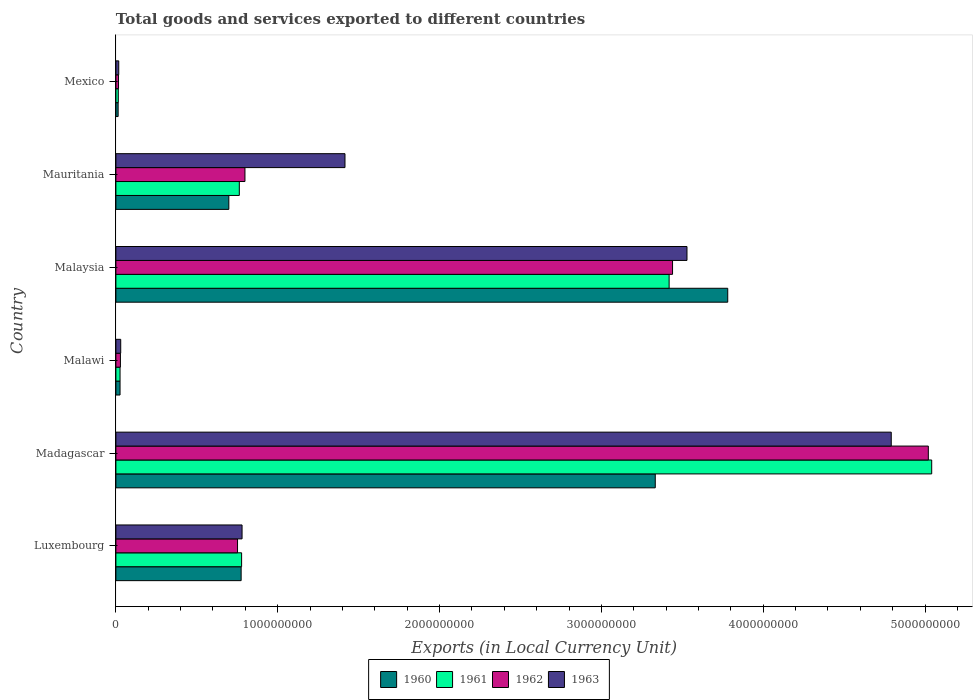How many different coloured bars are there?
Your answer should be compact. 4. How many bars are there on the 3rd tick from the top?
Your answer should be very brief. 4. What is the label of the 5th group of bars from the top?
Keep it short and to the point. Madagascar. What is the Amount of goods and services exports in 1962 in Luxembourg?
Provide a succinct answer. 7.52e+08. Across all countries, what is the maximum Amount of goods and services exports in 1960?
Your answer should be very brief. 3.78e+09. Across all countries, what is the minimum Amount of goods and services exports in 1960?
Make the answer very short. 1.39e+07. In which country was the Amount of goods and services exports in 1961 maximum?
Your answer should be compact. Madagascar. In which country was the Amount of goods and services exports in 1960 minimum?
Offer a very short reply. Mexico. What is the total Amount of goods and services exports in 1960 in the graph?
Your answer should be compact. 8.63e+09. What is the difference between the Amount of goods and services exports in 1963 in Madagascar and that in Mexico?
Provide a short and direct response. 4.77e+09. What is the difference between the Amount of goods and services exports in 1961 in Luxembourg and the Amount of goods and services exports in 1960 in Malawi?
Give a very brief answer. 7.51e+08. What is the average Amount of goods and services exports in 1961 per country?
Your response must be concise. 1.67e+09. What is the difference between the Amount of goods and services exports in 1962 and Amount of goods and services exports in 1960 in Malaysia?
Keep it short and to the point. -3.41e+08. In how many countries, is the Amount of goods and services exports in 1961 greater than 200000000 LCU?
Your answer should be compact. 4. What is the ratio of the Amount of goods and services exports in 1963 in Luxembourg to that in Malawi?
Ensure brevity in your answer.  26.16. Is the difference between the Amount of goods and services exports in 1962 in Mauritania and Mexico greater than the difference between the Amount of goods and services exports in 1960 in Mauritania and Mexico?
Offer a very short reply. Yes. What is the difference between the highest and the second highest Amount of goods and services exports in 1960?
Offer a terse response. 4.48e+08. What is the difference between the highest and the lowest Amount of goods and services exports in 1963?
Ensure brevity in your answer.  4.77e+09. In how many countries, is the Amount of goods and services exports in 1960 greater than the average Amount of goods and services exports in 1960 taken over all countries?
Your answer should be compact. 2. Is it the case that in every country, the sum of the Amount of goods and services exports in 1960 and Amount of goods and services exports in 1961 is greater than the sum of Amount of goods and services exports in 1963 and Amount of goods and services exports in 1962?
Provide a short and direct response. No. Is it the case that in every country, the sum of the Amount of goods and services exports in 1960 and Amount of goods and services exports in 1963 is greater than the Amount of goods and services exports in 1961?
Make the answer very short. Yes. Are all the bars in the graph horizontal?
Your answer should be compact. Yes. What is the title of the graph?
Ensure brevity in your answer.  Total goods and services exported to different countries. What is the label or title of the X-axis?
Your answer should be compact. Exports (in Local Currency Unit). What is the label or title of the Y-axis?
Ensure brevity in your answer.  Country. What is the Exports (in Local Currency Unit) in 1960 in Luxembourg?
Your response must be concise. 7.74e+08. What is the Exports (in Local Currency Unit) of 1961 in Luxembourg?
Give a very brief answer. 7.77e+08. What is the Exports (in Local Currency Unit) of 1962 in Luxembourg?
Your answer should be very brief. 7.52e+08. What is the Exports (in Local Currency Unit) in 1963 in Luxembourg?
Ensure brevity in your answer.  7.80e+08. What is the Exports (in Local Currency Unit) of 1960 in Madagascar?
Offer a terse response. 3.33e+09. What is the Exports (in Local Currency Unit) in 1961 in Madagascar?
Offer a very short reply. 5.04e+09. What is the Exports (in Local Currency Unit) in 1962 in Madagascar?
Provide a short and direct response. 5.02e+09. What is the Exports (in Local Currency Unit) of 1963 in Madagascar?
Offer a very short reply. 4.79e+09. What is the Exports (in Local Currency Unit) of 1960 in Malawi?
Give a very brief answer. 2.57e+07. What is the Exports (in Local Currency Unit) of 1961 in Malawi?
Give a very brief answer. 2.57e+07. What is the Exports (in Local Currency Unit) of 1962 in Malawi?
Keep it short and to the point. 2.80e+07. What is the Exports (in Local Currency Unit) of 1963 in Malawi?
Offer a terse response. 2.98e+07. What is the Exports (in Local Currency Unit) in 1960 in Malaysia?
Offer a very short reply. 3.78e+09. What is the Exports (in Local Currency Unit) of 1961 in Malaysia?
Offer a terse response. 3.42e+09. What is the Exports (in Local Currency Unit) of 1962 in Malaysia?
Your answer should be very brief. 3.44e+09. What is the Exports (in Local Currency Unit) of 1963 in Malaysia?
Provide a succinct answer. 3.53e+09. What is the Exports (in Local Currency Unit) in 1960 in Mauritania?
Keep it short and to the point. 6.98e+08. What is the Exports (in Local Currency Unit) of 1961 in Mauritania?
Provide a succinct answer. 7.63e+08. What is the Exports (in Local Currency Unit) of 1962 in Mauritania?
Your answer should be very brief. 7.98e+08. What is the Exports (in Local Currency Unit) of 1963 in Mauritania?
Offer a very short reply. 1.42e+09. What is the Exports (in Local Currency Unit) of 1960 in Mexico?
Give a very brief answer. 1.39e+07. What is the Exports (in Local Currency Unit) in 1961 in Mexico?
Ensure brevity in your answer.  1.49e+07. What is the Exports (in Local Currency Unit) in 1962 in Mexico?
Give a very brief answer. 1.63e+07. What is the Exports (in Local Currency Unit) of 1963 in Mexico?
Offer a terse response. 1.76e+07. Across all countries, what is the maximum Exports (in Local Currency Unit) of 1960?
Give a very brief answer. 3.78e+09. Across all countries, what is the maximum Exports (in Local Currency Unit) in 1961?
Provide a succinct answer. 5.04e+09. Across all countries, what is the maximum Exports (in Local Currency Unit) of 1962?
Keep it short and to the point. 5.02e+09. Across all countries, what is the maximum Exports (in Local Currency Unit) of 1963?
Keep it short and to the point. 4.79e+09. Across all countries, what is the minimum Exports (in Local Currency Unit) of 1960?
Your answer should be very brief. 1.39e+07. Across all countries, what is the minimum Exports (in Local Currency Unit) of 1961?
Give a very brief answer. 1.49e+07. Across all countries, what is the minimum Exports (in Local Currency Unit) in 1962?
Offer a terse response. 1.63e+07. Across all countries, what is the minimum Exports (in Local Currency Unit) in 1963?
Offer a very short reply. 1.76e+07. What is the total Exports (in Local Currency Unit) of 1960 in the graph?
Your answer should be compact. 8.63e+09. What is the total Exports (in Local Currency Unit) in 1961 in the graph?
Give a very brief answer. 1.00e+1. What is the total Exports (in Local Currency Unit) in 1962 in the graph?
Make the answer very short. 1.01e+1. What is the total Exports (in Local Currency Unit) of 1963 in the graph?
Keep it short and to the point. 1.06e+1. What is the difference between the Exports (in Local Currency Unit) of 1960 in Luxembourg and that in Madagascar?
Provide a succinct answer. -2.56e+09. What is the difference between the Exports (in Local Currency Unit) in 1961 in Luxembourg and that in Madagascar?
Offer a very short reply. -4.26e+09. What is the difference between the Exports (in Local Currency Unit) of 1962 in Luxembourg and that in Madagascar?
Provide a short and direct response. -4.27e+09. What is the difference between the Exports (in Local Currency Unit) in 1963 in Luxembourg and that in Madagascar?
Ensure brevity in your answer.  -4.01e+09. What is the difference between the Exports (in Local Currency Unit) of 1960 in Luxembourg and that in Malawi?
Offer a very short reply. 7.48e+08. What is the difference between the Exports (in Local Currency Unit) of 1961 in Luxembourg and that in Malawi?
Keep it short and to the point. 7.51e+08. What is the difference between the Exports (in Local Currency Unit) in 1962 in Luxembourg and that in Malawi?
Ensure brevity in your answer.  7.24e+08. What is the difference between the Exports (in Local Currency Unit) of 1963 in Luxembourg and that in Malawi?
Offer a terse response. 7.50e+08. What is the difference between the Exports (in Local Currency Unit) in 1960 in Luxembourg and that in Malaysia?
Provide a short and direct response. -3.01e+09. What is the difference between the Exports (in Local Currency Unit) of 1961 in Luxembourg and that in Malaysia?
Provide a short and direct response. -2.64e+09. What is the difference between the Exports (in Local Currency Unit) in 1962 in Luxembourg and that in Malaysia?
Your answer should be compact. -2.69e+09. What is the difference between the Exports (in Local Currency Unit) of 1963 in Luxembourg and that in Malaysia?
Your answer should be compact. -2.75e+09. What is the difference between the Exports (in Local Currency Unit) in 1960 in Luxembourg and that in Mauritania?
Ensure brevity in your answer.  7.61e+07. What is the difference between the Exports (in Local Currency Unit) of 1961 in Luxembourg and that in Mauritania?
Offer a terse response. 1.42e+07. What is the difference between the Exports (in Local Currency Unit) in 1962 in Luxembourg and that in Mauritania?
Make the answer very short. -4.59e+07. What is the difference between the Exports (in Local Currency Unit) of 1963 in Luxembourg and that in Mauritania?
Keep it short and to the point. -6.36e+08. What is the difference between the Exports (in Local Currency Unit) in 1960 in Luxembourg and that in Mexico?
Provide a short and direct response. 7.60e+08. What is the difference between the Exports (in Local Currency Unit) in 1961 in Luxembourg and that in Mexico?
Give a very brief answer. 7.62e+08. What is the difference between the Exports (in Local Currency Unit) of 1962 in Luxembourg and that in Mexico?
Keep it short and to the point. 7.35e+08. What is the difference between the Exports (in Local Currency Unit) of 1963 in Luxembourg and that in Mexico?
Keep it short and to the point. 7.62e+08. What is the difference between the Exports (in Local Currency Unit) in 1960 in Madagascar and that in Malawi?
Offer a terse response. 3.31e+09. What is the difference between the Exports (in Local Currency Unit) in 1961 in Madagascar and that in Malawi?
Keep it short and to the point. 5.02e+09. What is the difference between the Exports (in Local Currency Unit) of 1962 in Madagascar and that in Malawi?
Offer a terse response. 4.99e+09. What is the difference between the Exports (in Local Currency Unit) in 1963 in Madagascar and that in Malawi?
Provide a succinct answer. 4.76e+09. What is the difference between the Exports (in Local Currency Unit) in 1960 in Madagascar and that in Malaysia?
Offer a very short reply. -4.48e+08. What is the difference between the Exports (in Local Currency Unit) of 1961 in Madagascar and that in Malaysia?
Your answer should be very brief. 1.62e+09. What is the difference between the Exports (in Local Currency Unit) of 1962 in Madagascar and that in Malaysia?
Your answer should be very brief. 1.58e+09. What is the difference between the Exports (in Local Currency Unit) of 1963 in Madagascar and that in Malaysia?
Provide a short and direct response. 1.26e+09. What is the difference between the Exports (in Local Currency Unit) of 1960 in Madagascar and that in Mauritania?
Provide a succinct answer. 2.64e+09. What is the difference between the Exports (in Local Currency Unit) in 1961 in Madagascar and that in Mauritania?
Offer a very short reply. 4.28e+09. What is the difference between the Exports (in Local Currency Unit) of 1962 in Madagascar and that in Mauritania?
Your answer should be compact. 4.22e+09. What is the difference between the Exports (in Local Currency Unit) in 1963 in Madagascar and that in Mauritania?
Keep it short and to the point. 3.38e+09. What is the difference between the Exports (in Local Currency Unit) of 1960 in Madagascar and that in Mexico?
Your answer should be compact. 3.32e+09. What is the difference between the Exports (in Local Currency Unit) in 1961 in Madagascar and that in Mexico?
Ensure brevity in your answer.  5.03e+09. What is the difference between the Exports (in Local Currency Unit) in 1962 in Madagascar and that in Mexico?
Give a very brief answer. 5.00e+09. What is the difference between the Exports (in Local Currency Unit) in 1963 in Madagascar and that in Mexico?
Provide a succinct answer. 4.77e+09. What is the difference between the Exports (in Local Currency Unit) of 1960 in Malawi and that in Malaysia?
Ensure brevity in your answer.  -3.76e+09. What is the difference between the Exports (in Local Currency Unit) of 1961 in Malawi and that in Malaysia?
Ensure brevity in your answer.  -3.39e+09. What is the difference between the Exports (in Local Currency Unit) in 1962 in Malawi and that in Malaysia?
Your answer should be compact. -3.41e+09. What is the difference between the Exports (in Local Currency Unit) of 1963 in Malawi and that in Malaysia?
Offer a terse response. -3.50e+09. What is the difference between the Exports (in Local Currency Unit) in 1960 in Malawi and that in Mauritania?
Provide a short and direct response. -6.72e+08. What is the difference between the Exports (in Local Currency Unit) of 1961 in Malawi and that in Mauritania?
Provide a short and direct response. -7.37e+08. What is the difference between the Exports (in Local Currency Unit) in 1962 in Malawi and that in Mauritania?
Ensure brevity in your answer.  -7.70e+08. What is the difference between the Exports (in Local Currency Unit) in 1963 in Malawi and that in Mauritania?
Your answer should be very brief. -1.39e+09. What is the difference between the Exports (in Local Currency Unit) in 1960 in Malawi and that in Mexico?
Give a very brief answer. 1.18e+07. What is the difference between the Exports (in Local Currency Unit) in 1961 in Malawi and that in Mexico?
Provide a short and direct response. 1.08e+07. What is the difference between the Exports (in Local Currency Unit) in 1962 in Malawi and that in Mexico?
Give a very brief answer. 1.17e+07. What is the difference between the Exports (in Local Currency Unit) of 1963 in Malawi and that in Mexico?
Keep it short and to the point. 1.22e+07. What is the difference between the Exports (in Local Currency Unit) of 1960 in Malaysia and that in Mauritania?
Keep it short and to the point. 3.08e+09. What is the difference between the Exports (in Local Currency Unit) in 1961 in Malaysia and that in Mauritania?
Your response must be concise. 2.66e+09. What is the difference between the Exports (in Local Currency Unit) in 1962 in Malaysia and that in Mauritania?
Provide a succinct answer. 2.64e+09. What is the difference between the Exports (in Local Currency Unit) of 1963 in Malaysia and that in Mauritania?
Provide a succinct answer. 2.11e+09. What is the difference between the Exports (in Local Currency Unit) in 1960 in Malaysia and that in Mexico?
Provide a short and direct response. 3.77e+09. What is the difference between the Exports (in Local Currency Unit) of 1961 in Malaysia and that in Mexico?
Provide a short and direct response. 3.40e+09. What is the difference between the Exports (in Local Currency Unit) of 1962 in Malaysia and that in Mexico?
Provide a short and direct response. 3.42e+09. What is the difference between the Exports (in Local Currency Unit) in 1963 in Malaysia and that in Mexico?
Ensure brevity in your answer.  3.51e+09. What is the difference between the Exports (in Local Currency Unit) of 1960 in Mauritania and that in Mexico?
Give a very brief answer. 6.84e+08. What is the difference between the Exports (in Local Currency Unit) of 1961 in Mauritania and that in Mexico?
Your answer should be very brief. 7.48e+08. What is the difference between the Exports (in Local Currency Unit) in 1962 in Mauritania and that in Mexico?
Offer a terse response. 7.81e+08. What is the difference between the Exports (in Local Currency Unit) in 1963 in Mauritania and that in Mexico?
Make the answer very short. 1.40e+09. What is the difference between the Exports (in Local Currency Unit) of 1960 in Luxembourg and the Exports (in Local Currency Unit) of 1961 in Madagascar?
Keep it short and to the point. -4.27e+09. What is the difference between the Exports (in Local Currency Unit) of 1960 in Luxembourg and the Exports (in Local Currency Unit) of 1962 in Madagascar?
Provide a succinct answer. -4.25e+09. What is the difference between the Exports (in Local Currency Unit) of 1960 in Luxembourg and the Exports (in Local Currency Unit) of 1963 in Madagascar?
Provide a short and direct response. -4.02e+09. What is the difference between the Exports (in Local Currency Unit) of 1961 in Luxembourg and the Exports (in Local Currency Unit) of 1962 in Madagascar?
Provide a short and direct response. -4.24e+09. What is the difference between the Exports (in Local Currency Unit) of 1961 in Luxembourg and the Exports (in Local Currency Unit) of 1963 in Madagascar?
Your answer should be compact. -4.01e+09. What is the difference between the Exports (in Local Currency Unit) in 1962 in Luxembourg and the Exports (in Local Currency Unit) in 1963 in Madagascar?
Provide a short and direct response. -4.04e+09. What is the difference between the Exports (in Local Currency Unit) of 1960 in Luxembourg and the Exports (in Local Currency Unit) of 1961 in Malawi?
Offer a very short reply. 7.48e+08. What is the difference between the Exports (in Local Currency Unit) of 1960 in Luxembourg and the Exports (in Local Currency Unit) of 1962 in Malawi?
Your answer should be very brief. 7.46e+08. What is the difference between the Exports (in Local Currency Unit) in 1960 in Luxembourg and the Exports (in Local Currency Unit) in 1963 in Malawi?
Make the answer very short. 7.44e+08. What is the difference between the Exports (in Local Currency Unit) in 1961 in Luxembourg and the Exports (in Local Currency Unit) in 1962 in Malawi?
Your answer should be very brief. 7.49e+08. What is the difference between the Exports (in Local Currency Unit) of 1961 in Luxembourg and the Exports (in Local Currency Unit) of 1963 in Malawi?
Ensure brevity in your answer.  7.47e+08. What is the difference between the Exports (in Local Currency Unit) of 1962 in Luxembourg and the Exports (in Local Currency Unit) of 1963 in Malawi?
Ensure brevity in your answer.  7.22e+08. What is the difference between the Exports (in Local Currency Unit) in 1960 in Luxembourg and the Exports (in Local Currency Unit) in 1961 in Malaysia?
Keep it short and to the point. -2.64e+09. What is the difference between the Exports (in Local Currency Unit) of 1960 in Luxembourg and the Exports (in Local Currency Unit) of 1962 in Malaysia?
Your answer should be compact. -2.67e+09. What is the difference between the Exports (in Local Currency Unit) in 1960 in Luxembourg and the Exports (in Local Currency Unit) in 1963 in Malaysia?
Give a very brief answer. -2.76e+09. What is the difference between the Exports (in Local Currency Unit) in 1961 in Luxembourg and the Exports (in Local Currency Unit) in 1962 in Malaysia?
Offer a very short reply. -2.66e+09. What is the difference between the Exports (in Local Currency Unit) of 1961 in Luxembourg and the Exports (in Local Currency Unit) of 1963 in Malaysia?
Provide a succinct answer. -2.75e+09. What is the difference between the Exports (in Local Currency Unit) in 1962 in Luxembourg and the Exports (in Local Currency Unit) in 1963 in Malaysia?
Your response must be concise. -2.78e+09. What is the difference between the Exports (in Local Currency Unit) of 1960 in Luxembourg and the Exports (in Local Currency Unit) of 1961 in Mauritania?
Offer a terse response. 1.13e+07. What is the difference between the Exports (in Local Currency Unit) in 1960 in Luxembourg and the Exports (in Local Currency Unit) in 1962 in Mauritania?
Provide a short and direct response. -2.36e+07. What is the difference between the Exports (in Local Currency Unit) of 1960 in Luxembourg and the Exports (in Local Currency Unit) of 1963 in Mauritania?
Your answer should be compact. -6.42e+08. What is the difference between the Exports (in Local Currency Unit) in 1961 in Luxembourg and the Exports (in Local Currency Unit) in 1962 in Mauritania?
Your answer should be compact. -2.07e+07. What is the difference between the Exports (in Local Currency Unit) in 1961 in Luxembourg and the Exports (in Local Currency Unit) in 1963 in Mauritania?
Your answer should be very brief. -6.39e+08. What is the difference between the Exports (in Local Currency Unit) in 1962 in Luxembourg and the Exports (in Local Currency Unit) in 1963 in Mauritania?
Ensure brevity in your answer.  -6.64e+08. What is the difference between the Exports (in Local Currency Unit) in 1960 in Luxembourg and the Exports (in Local Currency Unit) in 1961 in Mexico?
Make the answer very short. 7.59e+08. What is the difference between the Exports (in Local Currency Unit) in 1960 in Luxembourg and the Exports (in Local Currency Unit) in 1962 in Mexico?
Give a very brief answer. 7.58e+08. What is the difference between the Exports (in Local Currency Unit) in 1960 in Luxembourg and the Exports (in Local Currency Unit) in 1963 in Mexico?
Provide a succinct answer. 7.56e+08. What is the difference between the Exports (in Local Currency Unit) of 1961 in Luxembourg and the Exports (in Local Currency Unit) of 1962 in Mexico?
Your answer should be compact. 7.61e+08. What is the difference between the Exports (in Local Currency Unit) in 1961 in Luxembourg and the Exports (in Local Currency Unit) in 1963 in Mexico?
Keep it short and to the point. 7.59e+08. What is the difference between the Exports (in Local Currency Unit) of 1962 in Luxembourg and the Exports (in Local Currency Unit) of 1963 in Mexico?
Keep it short and to the point. 7.34e+08. What is the difference between the Exports (in Local Currency Unit) in 1960 in Madagascar and the Exports (in Local Currency Unit) in 1961 in Malawi?
Make the answer very short. 3.31e+09. What is the difference between the Exports (in Local Currency Unit) in 1960 in Madagascar and the Exports (in Local Currency Unit) in 1962 in Malawi?
Your response must be concise. 3.31e+09. What is the difference between the Exports (in Local Currency Unit) in 1960 in Madagascar and the Exports (in Local Currency Unit) in 1963 in Malawi?
Offer a terse response. 3.30e+09. What is the difference between the Exports (in Local Currency Unit) in 1961 in Madagascar and the Exports (in Local Currency Unit) in 1962 in Malawi?
Keep it short and to the point. 5.01e+09. What is the difference between the Exports (in Local Currency Unit) of 1961 in Madagascar and the Exports (in Local Currency Unit) of 1963 in Malawi?
Give a very brief answer. 5.01e+09. What is the difference between the Exports (in Local Currency Unit) in 1962 in Madagascar and the Exports (in Local Currency Unit) in 1963 in Malawi?
Ensure brevity in your answer.  4.99e+09. What is the difference between the Exports (in Local Currency Unit) in 1960 in Madagascar and the Exports (in Local Currency Unit) in 1961 in Malaysia?
Make the answer very short. -8.57e+07. What is the difference between the Exports (in Local Currency Unit) of 1960 in Madagascar and the Exports (in Local Currency Unit) of 1962 in Malaysia?
Your answer should be very brief. -1.07e+08. What is the difference between the Exports (in Local Currency Unit) of 1960 in Madagascar and the Exports (in Local Currency Unit) of 1963 in Malaysia?
Keep it short and to the point. -1.96e+08. What is the difference between the Exports (in Local Currency Unit) in 1961 in Madagascar and the Exports (in Local Currency Unit) in 1962 in Malaysia?
Give a very brief answer. 1.60e+09. What is the difference between the Exports (in Local Currency Unit) of 1961 in Madagascar and the Exports (in Local Currency Unit) of 1963 in Malaysia?
Provide a short and direct response. 1.51e+09. What is the difference between the Exports (in Local Currency Unit) in 1962 in Madagascar and the Exports (in Local Currency Unit) in 1963 in Malaysia?
Make the answer very short. 1.49e+09. What is the difference between the Exports (in Local Currency Unit) in 1960 in Madagascar and the Exports (in Local Currency Unit) in 1961 in Mauritania?
Your answer should be very brief. 2.57e+09. What is the difference between the Exports (in Local Currency Unit) in 1960 in Madagascar and the Exports (in Local Currency Unit) in 1962 in Mauritania?
Your answer should be very brief. 2.54e+09. What is the difference between the Exports (in Local Currency Unit) in 1960 in Madagascar and the Exports (in Local Currency Unit) in 1963 in Mauritania?
Keep it short and to the point. 1.92e+09. What is the difference between the Exports (in Local Currency Unit) in 1961 in Madagascar and the Exports (in Local Currency Unit) in 1962 in Mauritania?
Your answer should be very brief. 4.24e+09. What is the difference between the Exports (in Local Currency Unit) of 1961 in Madagascar and the Exports (in Local Currency Unit) of 1963 in Mauritania?
Your response must be concise. 3.63e+09. What is the difference between the Exports (in Local Currency Unit) in 1962 in Madagascar and the Exports (in Local Currency Unit) in 1963 in Mauritania?
Provide a succinct answer. 3.60e+09. What is the difference between the Exports (in Local Currency Unit) of 1960 in Madagascar and the Exports (in Local Currency Unit) of 1961 in Mexico?
Ensure brevity in your answer.  3.32e+09. What is the difference between the Exports (in Local Currency Unit) of 1960 in Madagascar and the Exports (in Local Currency Unit) of 1962 in Mexico?
Your answer should be very brief. 3.32e+09. What is the difference between the Exports (in Local Currency Unit) in 1960 in Madagascar and the Exports (in Local Currency Unit) in 1963 in Mexico?
Provide a short and direct response. 3.32e+09. What is the difference between the Exports (in Local Currency Unit) of 1961 in Madagascar and the Exports (in Local Currency Unit) of 1962 in Mexico?
Give a very brief answer. 5.02e+09. What is the difference between the Exports (in Local Currency Unit) in 1961 in Madagascar and the Exports (in Local Currency Unit) in 1963 in Mexico?
Your response must be concise. 5.02e+09. What is the difference between the Exports (in Local Currency Unit) of 1962 in Madagascar and the Exports (in Local Currency Unit) of 1963 in Mexico?
Your answer should be compact. 5.00e+09. What is the difference between the Exports (in Local Currency Unit) in 1960 in Malawi and the Exports (in Local Currency Unit) in 1961 in Malaysia?
Ensure brevity in your answer.  -3.39e+09. What is the difference between the Exports (in Local Currency Unit) in 1960 in Malawi and the Exports (in Local Currency Unit) in 1962 in Malaysia?
Provide a succinct answer. -3.41e+09. What is the difference between the Exports (in Local Currency Unit) in 1960 in Malawi and the Exports (in Local Currency Unit) in 1963 in Malaysia?
Make the answer very short. -3.50e+09. What is the difference between the Exports (in Local Currency Unit) in 1961 in Malawi and the Exports (in Local Currency Unit) in 1962 in Malaysia?
Your answer should be very brief. -3.41e+09. What is the difference between the Exports (in Local Currency Unit) in 1961 in Malawi and the Exports (in Local Currency Unit) in 1963 in Malaysia?
Ensure brevity in your answer.  -3.50e+09. What is the difference between the Exports (in Local Currency Unit) in 1962 in Malawi and the Exports (in Local Currency Unit) in 1963 in Malaysia?
Ensure brevity in your answer.  -3.50e+09. What is the difference between the Exports (in Local Currency Unit) in 1960 in Malawi and the Exports (in Local Currency Unit) in 1961 in Mauritania?
Offer a very short reply. -7.37e+08. What is the difference between the Exports (in Local Currency Unit) in 1960 in Malawi and the Exports (in Local Currency Unit) in 1962 in Mauritania?
Offer a terse response. -7.72e+08. What is the difference between the Exports (in Local Currency Unit) in 1960 in Malawi and the Exports (in Local Currency Unit) in 1963 in Mauritania?
Provide a succinct answer. -1.39e+09. What is the difference between the Exports (in Local Currency Unit) in 1961 in Malawi and the Exports (in Local Currency Unit) in 1962 in Mauritania?
Your response must be concise. -7.72e+08. What is the difference between the Exports (in Local Currency Unit) of 1961 in Malawi and the Exports (in Local Currency Unit) of 1963 in Mauritania?
Your answer should be compact. -1.39e+09. What is the difference between the Exports (in Local Currency Unit) of 1962 in Malawi and the Exports (in Local Currency Unit) of 1963 in Mauritania?
Keep it short and to the point. -1.39e+09. What is the difference between the Exports (in Local Currency Unit) of 1960 in Malawi and the Exports (in Local Currency Unit) of 1961 in Mexico?
Offer a terse response. 1.08e+07. What is the difference between the Exports (in Local Currency Unit) in 1960 in Malawi and the Exports (in Local Currency Unit) in 1962 in Mexico?
Your response must be concise. 9.42e+06. What is the difference between the Exports (in Local Currency Unit) of 1960 in Malawi and the Exports (in Local Currency Unit) of 1963 in Mexico?
Give a very brief answer. 8.06e+06. What is the difference between the Exports (in Local Currency Unit) in 1961 in Malawi and the Exports (in Local Currency Unit) in 1962 in Mexico?
Ensure brevity in your answer.  9.42e+06. What is the difference between the Exports (in Local Currency Unit) of 1961 in Malawi and the Exports (in Local Currency Unit) of 1963 in Mexico?
Ensure brevity in your answer.  8.06e+06. What is the difference between the Exports (in Local Currency Unit) in 1962 in Malawi and the Exports (in Local Currency Unit) in 1963 in Mexico?
Your answer should be very brief. 1.04e+07. What is the difference between the Exports (in Local Currency Unit) of 1960 in Malaysia and the Exports (in Local Currency Unit) of 1961 in Mauritania?
Offer a terse response. 3.02e+09. What is the difference between the Exports (in Local Currency Unit) of 1960 in Malaysia and the Exports (in Local Currency Unit) of 1962 in Mauritania?
Provide a short and direct response. 2.98e+09. What is the difference between the Exports (in Local Currency Unit) of 1960 in Malaysia and the Exports (in Local Currency Unit) of 1963 in Mauritania?
Your answer should be very brief. 2.37e+09. What is the difference between the Exports (in Local Currency Unit) in 1961 in Malaysia and the Exports (in Local Currency Unit) in 1962 in Mauritania?
Offer a very short reply. 2.62e+09. What is the difference between the Exports (in Local Currency Unit) of 1961 in Malaysia and the Exports (in Local Currency Unit) of 1963 in Mauritania?
Offer a terse response. 2.00e+09. What is the difference between the Exports (in Local Currency Unit) in 1962 in Malaysia and the Exports (in Local Currency Unit) in 1963 in Mauritania?
Provide a succinct answer. 2.02e+09. What is the difference between the Exports (in Local Currency Unit) of 1960 in Malaysia and the Exports (in Local Currency Unit) of 1961 in Mexico?
Your answer should be very brief. 3.77e+09. What is the difference between the Exports (in Local Currency Unit) of 1960 in Malaysia and the Exports (in Local Currency Unit) of 1962 in Mexico?
Offer a terse response. 3.76e+09. What is the difference between the Exports (in Local Currency Unit) of 1960 in Malaysia and the Exports (in Local Currency Unit) of 1963 in Mexico?
Your answer should be compact. 3.76e+09. What is the difference between the Exports (in Local Currency Unit) in 1961 in Malaysia and the Exports (in Local Currency Unit) in 1962 in Mexico?
Your answer should be compact. 3.40e+09. What is the difference between the Exports (in Local Currency Unit) of 1961 in Malaysia and the Exports (in Local Currency Unit) of 1963 in Mexico?
Give a very brief answer. 3.40e+09. What is the difference between the Exports (in Local Currency Unit) of 1962 in Malaysia and the Exports (in Local Currency Unit) of 1963 in Mexico?
Give a very brief answer. 3.42e+09. What is the difference between the Exports (in Local Currency Unit) in 1960 in Mauritania and the Exports (in Local Currency Unit) in 1961 in Mexico?
Your answer should be very brief. 6.83e+08. What is the difference between the Exports (in Local Currency Unit) in 1960 in Mauritania and the Exports (in Local Currency Unit) in 1962 in Mexico?
Make the answer very short. 6.82e+08. What is the difference between the Exports (in Local Currency Unit) in 1960 in Mauritania and the Exports (in Local Currency Unit) in 1963 in Mexico?
Keep it short and to the point. 6.80e+08. What is the difference between the Exports (in Local Currency Unit) in 1961 in Mauritania and the Exports (in Local Currency Unit) in 1962 in Mexico?
Provide a short and direct response. 7.46e+08. What is the difference between the Exports (in Local Currency Unit) in 1961 in Mauritania and the Exports (in Local Currency Unit) in 1963 in Mexico?
Keep it short and to the point. 7.45e+08. What is the difference between the Exports (in Local Currency Unit) of 1962 in Mauritania and the Exports (in Local Currency Unit) of 1963 in Mexico?
Offer a terse response. 7.80e+08. What is the average Exports (in Local Currency Unit) in 1960 per country?
Ensure brevity in your answer.  1.44e+09. What is the average Exports (in Local Currency Unit) of 1961 per country?
Your response must be concise. 1.67e+09. What is the average Exports (in Local Currency Unit) in 1962 per country?
Offer a very short reply. 1.68e+09. What is the average Exports (in Local Currency Unit) of 1963 per country?
Your answer should be very brief. 1.76e+09. What is the difference between the Exports (in Local Currency Unit) in 1960 and Exports (in Local Currency Unit) in 1961 in Luxembourg?
Ensure brevity in your answer.  -2.86e+06. What is the difference between the Exports (in Local Currency Unit) in 1960 and Exports (in Local Currency Unit) in 1962 in Luxembourg?
Your response must be concise. 2.23e+07. What is the difference between the Exports (in Local Currency Unit) of 1960 and Exports (in Local Currency Unit) of 1963 in Luxembourg?
Give a very brief answer. -5.65e+06. What is the difference between the Exports (in Local Currency Unit) in 1961 and Exports (in Local Currency Unit) in 1962 in Luxembourg?
Your answer should be compact. 2.52e+07. What is the difference between the Exports (in Local Currency Unit) of 1961 and Exports (in Local Currency Unit) of 1963 in Luxembourg?
Provide a short and direct response. -2.79e+06. What is the difference between the Exports (in Local Currency Unit) of 1962 and Exports (in Local Currency Unit) of 1963 in Luxembourg?
Offer a very short reply. -2.80e+07. What is the difference between the Exports (in Local Currency Unit) of 1960 and Exports (in Local Currency Unit) of 1961 in Madagascar?
Your response must be concise. -1.71e+09. What is the difference between the Exports (in Local Currency Unit) in 1960 and Exports (in Local Currency Unit) in 1962 in Madagascar?
Keep it short and to the point. -1.69e+09. What is the difference between the Exports (in Local Currency Unit) of 1960 and Exports (in Local Currency Unit) of 1963 in Madagascar?
Your answer should be very brief. -1.46e+09. What is the difference between the Exports (in Local Currency Unit) of 1961 and Exports (in Local Currency Unit) of 1962 in Madagascar?
Provide a succinct answer. 2.08e+07. What is the difference between the Exports (in Local Currency Unit) in 1961 and Exports (in Local Currency Unit) in 1963 in Madagascar?
Your answer should be very brief. 2.50e+08. What is the difference between the Exports (in Local Currency Unit) in 1962 and Exports (in Local Currency Unit) in 1963 in Madagascar?
Provide a short and direct response. 2.29e+08. What is the difference between the Exports (in Local Currency Unit) in 1960 and Exports (in Local Currency Unit) in 1962 in Malawi?
Make the answer very short. -2.30e+06. What is the difference between the Exports (in Local Currency Unit) of 1960 and Exports (in Local Currency Unit) of 1963 in Malawi?
Offer a very short reply. -4.10e+06. What is the difference between the Exports (in Local Currency Unit) in 1961 and Exports (in Local Currency Unit) in 1962 in Malawi?
Offer a very short reply. -2.30e+06. What is the difference between the Exports (in Local Currency Unit) of 1961 and Exports (in Local Currency Unit) of 1963 in Malawi?
Offer a terse response. -4.10e+06. What is the difference between the Exports (in Local Currency Unit) in 1962 and Exports (in Local Currency Unit) in 1963 in Malawi?
Provide a short and direct response. -1.80e+06. What is the difference between the Exports (in Local Currency Unit) in 1960 and Exports (in Local Currency Unit) in 1961 in Malaysia?
Offer a terse response. 3.62e+08. What is the difference between the Exports (in Local Currency Unit) of 1960 and Exports (in Local Currency Unit) of 1962 in Malaysia?
Ensure brevity in your answer.  3.41e+08. What is the difference between the Exports (in Local Currency Unit) of 1960 and Exports (in Local Currency Unit) of 1963 in Malaysia?
Make the answer very short. 2.52e+08. What is the difference between the Exports (in Local Currency Unit) of 1961 and Exports (in Local Currency Unit) of 1962 in Malaysia?
Your answer should be compact. -2.11e+07. What is the difference between the Exports (in Local Currency Unit) in 1961 and Exports (in Local Currency Unit) in 1963 in Malaysia?
Ensure brevity in your answer.  -1.10e+08. What is the difference between the Exports (in Local Currency Unit) in 1962 and Exports (in Local Currency Unit) in 1963 in Malaysia?
Make the answer very short. -8.93e+07. What is the difference between the Exports (in Local Currency Unit) of 1960 and Exports (in Local Currency Unit) of 1961 in Mauritania?
Make the answer very short. -6.48e+07. What is the difference between the Exports (in Local Currency Unit) in 1960 and Exports (in Local Currency Unit) in 1962 in Mauritania?
Ensure brevity in your answer.  -9.97e+07. What is the difference between the Exports (in Local Currency Unit) of 1960 and Exports (in Local Currency Unit) of 1963 in Mauritania?
Offer a very short reply. -7.18e+08. What is the difference between the Exports (in Local Currency Unit) in 1961 and Exports (in Local Currency Unit) in 1962 in Mauritania?
Offer a terse response. -3.49e+07. What is the difference between the Exports (in Local Currency Unit) of 1961 and Exports (in Local Currency Unit) of 1963 in Mauritania?
Provide a short and direct response. -6.53e+08. What is the difference between the Exports (in Local Currency Unit) of 1962 and Exports (in Local Currency Unit) of 1963 in Mauritania?
Provide a short and direct response. -6.18e+08. What is the difference between the Exports (in Local Currency Unit) of 1960 and Exports (in Local Currency Unit) of 1961 in Mexico?
Ensure brevity in your answer.  -1.03e+06. What is the difference between the Exports (in Local Currency Unit) in 1960 and Exports (in Local Currency Unit) in 1962 in Mexico?
Offer a very short reply. -2.42e+06. What is the difference between the Exports (in Local Currency Unit) in 1960 and Exports (in Local Currency Unit) in 1963 in Mexico?
Ensure brevity in your answer.  -3.77e+06. What is the difference between the Exports (in Local Currency Unit) of 1961 and Exports (in Local Currency Unit) of 1962 in Mexico?
Offer a very short reply. -1.39e+06. What is the difference between the Exports (in Local Currency Unit) of 1961 and Exports (in Local Currency Unit) of 1963 in Mexico?
Provide a succinct answer. -2.75e+06. What is the difference between the Exports (in Local Currency Unit) of 1962 and Exports (in Local Currency Unit) of 1963 in Mexico?
Offer a very short reply. -1.36e+06. What is the ratio of the Exports (in Local Currency Unit) of 1960 in Luxembourg to that in Madagascar?
Provide a succinct answer. 0.23. What is the ratio of the Exports (in Local Currency Unit) of 1961 in Luxembourg to that in Madagascar?
Give a very brief answer. 0.15. What is the ratio of the Exports (in Local Currency Unit) in 1962 in Luxembourg to that in Madagascar?
Make the answer very short. 0.15. What is the ratio of the Exports (in Local Currency Unit) of 1963 in Luxembourg to that in Madagascar?
Ensure brevity in your answer.  0.16. What is the ratio of the Exports (in Local Currency Unit) in 1960 in Luxembourg to that in Malawi?
Ensure brevity in your answer.  30.12. What is the ratio of the Exports (in Local Currency Unit) of 1961 in Luxembourg to that in Malawi?
Make the answer very short. 30.23. What is the ratio of the Exports (in Local Currency Unit) of 1962 in Luxembourg to that in Malawi?
Provide a succinct answer. 26.85. What is the ratio of the Exports (in Local Currency Unit) in 1963 in Luxembourg to that in Malawi?
Your answer should be compact. 26.16. What is the ratio of the Exports (in Local Currency Unit) of 1960 in Luxembourg to that in Malaysia?
Your answer should be compact. 0.2. What is the ratio of the Exports (in Local Currency Unit) of 1961 in Luxembourg to that in Malaysia?
Keep it short and to the point. 0.23. What is the ratio of the Exports (in Local Currency Unit) in 1962 in Luxembourg to that in Malaysia?
Offer a very short reply. 0.22. What is the ratio of the Exports (in Local Currency Unit) of 1963 in Luxembourg to that in Malaysia?
Your response must be concise. 0.22. What is the ratio of the Exports (in Local Currency Unit) in 1960 in Luxembourg to that in Mauritania?
Your response must be concise. 1.11. What is the ratio of the Exports (in Local Currency Unit) in 1961 in Luxembourg to that in Mauritania?
Make the answer very short. 1.02. What is the ratio of the Exports (in Local Currency Unit) of 1962 in Luxembourg to that in Mauritania?
Provide a short and direct response. 0.94. What is the ratio of the Exports (in Local Currency Unit) in 1963 in Luxembourg to that in Mauritania?
Provide a short and direct response. 0.55. What is the ratio of the Exports (in Local Currency Unit) in 1960 in Luxembourg to that in Mexico?
Your answer should be compact. 55.83. What is the ratio of the Exports (in Local Currency Unit) in 1961 in Luxembourg to that in Mexico?
Your answer should be very brief. 52.17. What is the ratio of the Exports (in Local Currency Unit) of 1962 in Luxembourg to that in Mexico?
Keep it short and to the point. 46.17. What is the ratio of the Exports (in Local Currency Unit) of 1963 in Luxembourg to that in Mexico?
Make the answer very short. 44.2. What is the ratio of the Exports (in Local Currency Unit) in 1960 in Madagascar to that in Malawi?
Offer a terse response. 129.69. What is the ratio of the Exports (in Local Currency Unit) of 1961 in Madagascar to that in Malawi?
Your answer should be compact. 196.16. What is the ratio of the Exports (in Local Currency Unit) of 1962 in Madagascar to that in Malawi?
Make the answer very short. 179.3. What is the ratio of the Exports (in Local Currency Unit) in 1963 in Madagascar to that in Malawi?
Provide a short and direct response. 160.78. What is the ratio of the Exports (in Local Currency Unit) in 1960 in Madagascar to that in Malaysia?
Your answer should be compact. 0.88. What is the ratio of the Exports (in Local Currency Unit) of 1961 in Madagascar to that in Malaysia?
Ensure brevity in your answer.  1.47. What is the ratio of the Exports (in Local Currency Unit) of 1962 in Madagascar to that in Malaysia?
Give a very brief answer. 1.46. What is the ratio of the Exports (in Local Currency Unit) of 1963 in Madagascar to that in Malaysia?
Make the answer very short. 1.36. What is the ratio of the Exports (in Local Currency Unit) of 1960 in Madagascar to that in Mauritania?
Offer a very short reply. 4.78. What is the ratio of the Exports (in Local Currency Unit) in 1961 in Madagascar to that in Mauritania?
Your answer should be very brief. 6.61. What is the ratio of the Exports (in Local Currency Unit) of 1962 in Madagascar to that in Mauritania?
Your response must be concise. 6.29. What is the ratio of the Exports (in Local Currency Unit) in 1963 in Madagascar to that in Mauritania?
Your answer should be compact. 3.38. What is the ratio of the Exports (in Local Currency Unit) of 1960 in Madagascar to that in Mexico?
Your answer should be compact. 240.41. What is the ratio of the Exports (in Local Currency Unit) in 1961 in Madagascar to that in Mexico?
Make the answer very short. 338.57. What is the ratio of the Exports (in Local Currency Unit) in 1962 in Madagascar to that in Mexico?
Give a very brief answer. 308.36. What is the ratio of the Exports (in Local Currency Unit) of 1963 in Madagascar to that in Mexico?
Your answer should be compact. 271.64. What is the ratio of the Exports (in Local Currency Unit) in 1960 in Malawi to that in Malaysia?
Your answer should be very brief. 0.01. What is the ratio of the Exports (in Local Currency Unit) of 1961 in Malawi to that in Malaysia?
Give a very brief answer. 0.01. What is the ratio of the Exports (in Local Currency Unit) of 1962 in Malawi to that in Malaysia?
Provide a succinct answer. 0.01. What is the ratio of the Exports (in Local Currency Unit) of 1963 in Malawi to that in Malaysia?
Ensure brevity in your answer.  0.01. What is the ratio of the Exports (in Local Currency Unit) in 1960 in Malawi to that in Mauritania?
Provide a succinct answer. 0.04. What is the ratio of the Exports (in Local Currency Unit) of 1961 in Malawi to that in Mauritania?
Give a very brief answer. 0.03. What is the ratio of the Exports (in Local Currency Unit) in 1962 in Malawi to that in Mauritania?
Your answer should be very brief. 0.04. What is the ratio of the Exports (in Local Currency Unit) of 1963 in Malawi to that in Mauritania?
Your answer should be very brief. 0.02. What is the ratio of the Exports (in Local Currency Unit) in 1960 in Malawi to that in Mexico?
Your response must be concise. 1.85. What is the ratio of the Exports (in Local Currency Unit) of 1961 in Malawi to that in Mexico?
Offer a very short reply. 1.73. What is the ratio of the Exports (in Local Currency Unit) in 1962 in Malawi to that in Mexico?
Ensure brevity in your answer.  1.72. What is the ratio of the Exports (in Local Currency Unit) of 1963 in Malawi to that in Mexico?
Your answer should be very brief. 1.69. What is the ratio of the Exports (in Local Currency Unit) in 1960 in Malaysia to that in Mauritania?
Your answer should be very brief. 5.42. What is the ratio of the Exports (in Local Currency Unit) of 1961 in Malaysia to that in Mauritania?
Your answer should be compact. 4.48. What is the ratio of the Exports (in Local Currency Unit) in 1962 in Malaysia to that in Mauritania?
Your response must be concise. 4.31. What is the ratio of the Exports (in Local Currency Unit) in 1963 in Malaysia to that in Mauritania?
Provide a short and direct response. 2.49. What is the ratio of the Exports (in Local Currency Unit) in 1960 in Malaysia to that in Mexico?
Keep it short and to the point. 272.71. What is the ratio of the Exports (in Local Currency Unit) in 1961 in Malaysia to that in Mexico?
Ensure brevity in your answer.  229.6. What is the ratio of the Exports (in Local Currency Unit) of 1962 in Malaysia to that in Mexico?
Ensure brevity in your answer.  211.27. What is the ratio of the Exports (in Local Currency Unit) in 1963 in Malaysia to that in Mexico?
Your answer should be very brief. 200.08. What is the ratio of the Exports (in Local Currency Unit) of 1960 in Mauritania to that in Mexico?
Your answer should be very brief. 50.34. What is the ratio of the Exports (in Local Currency Unit) of 1961 in Mauritania to that in Mexico?
Keep it short and to the point. 51.22. What is the ratio of the Exports (in Local Currency Unit) in 1962 in Mauritania to that in Mexico?
Make the answer very short. 48.99. What is the ratio of the Exports (in Local Currency Unit) in 1963 in Mauritania to that in Mexico?
Your response must be concise. 80.26. What is the difference between the highest and the second highest Exports (in Local Currency Unit) of 1960?
Your answer should be compact. 4.48e+08. What is the difference between the highest and the second highest Exports (in Local Currency Unit) of 1961?
Make the answer very short. 1.62e+09. What is the difference between the highest and the second highest Exports (in Local Currency Unit) of 1962?
Provide a succinct answer. 1.58e+09. What is the difference between the highest and the second highest Exports (in Local Currency Unit) in 1963?
Provide a succinct answer. 1.26e+09. What is the difference between the highest and the lowest Exports (in Local Currency Unit) of 1960?
Give a very brief answer. 3.77e+09. What is the difference between the highest and the lowest Exports (in Local Currency Unit) in 1961?
Offer a terse response. 5.03e+09. What is the difference between the highest and the lowest Exports (in Local Currency Unit) in 1962?
Offer a terse response. 5.00e+09. What is the difference between the highest and the lowest Exports (in Local Currency Unit) in 1963?
Your response must be concise. 4.77e+09. 